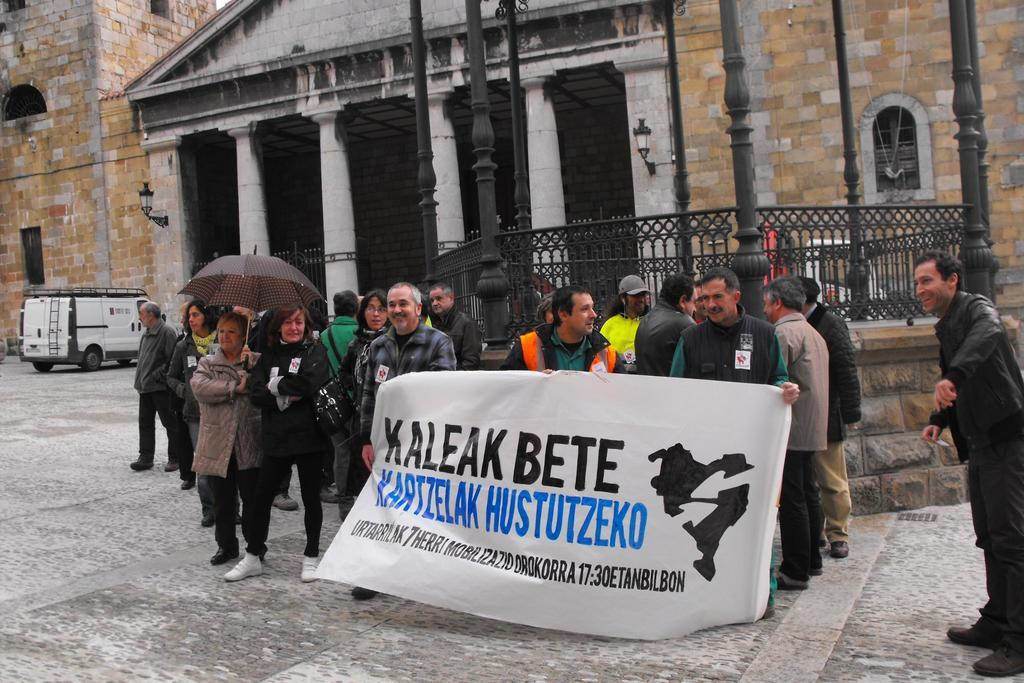What are the people in the image doing? The people in the image are protesting on the road. Can you describe any specific actions or objects related to the protest? Two persons are holding a banner with text on it. What can be seen in the background of the image? There is a big building and a van in the background. Is there a river flowing near the protesters in the image? No, there is no river visible in the image. What type of comb is being used by the protesters to hold their hair back? There is no comb present in the image, and the protesters' hair is not mentioned or visible. --- Facts: 1. There is a person sitting on a bench. 2. The person is reading a book. 3. The book has a blue cover. 4. There is a tree behind the bench. 5. The sky is visible above the tree. Absurd Topics: parrot, sandcastle, volcano Conversation: What is the person in the image doing? The person in the image is sitting on a bench and reading a book. Can you describe the book the person is reading? The book has a blue cover. What can be seen behind the bench in the image? There is a tree behind the bench. What is visible above the tree in the image? The sky is visible above the tree. Reasoning: Let's think step by step in order to produce the conversation. We start by identifying the main subject in the image, which is the person sitting on the bench. Then, we describe the specific action the person is engaged in, which is reading a book. We also mention the book's cover color and the background elements, including the tree and the sky. Absurd Question/Answer: Can you see a parrot perched on the tree in the image? No, there is no parrot visible in the image. Is there a sandcastle being built by the person sitting on the bench? No, there is no sandcastle present in the image, and the person is reading a book instead. 